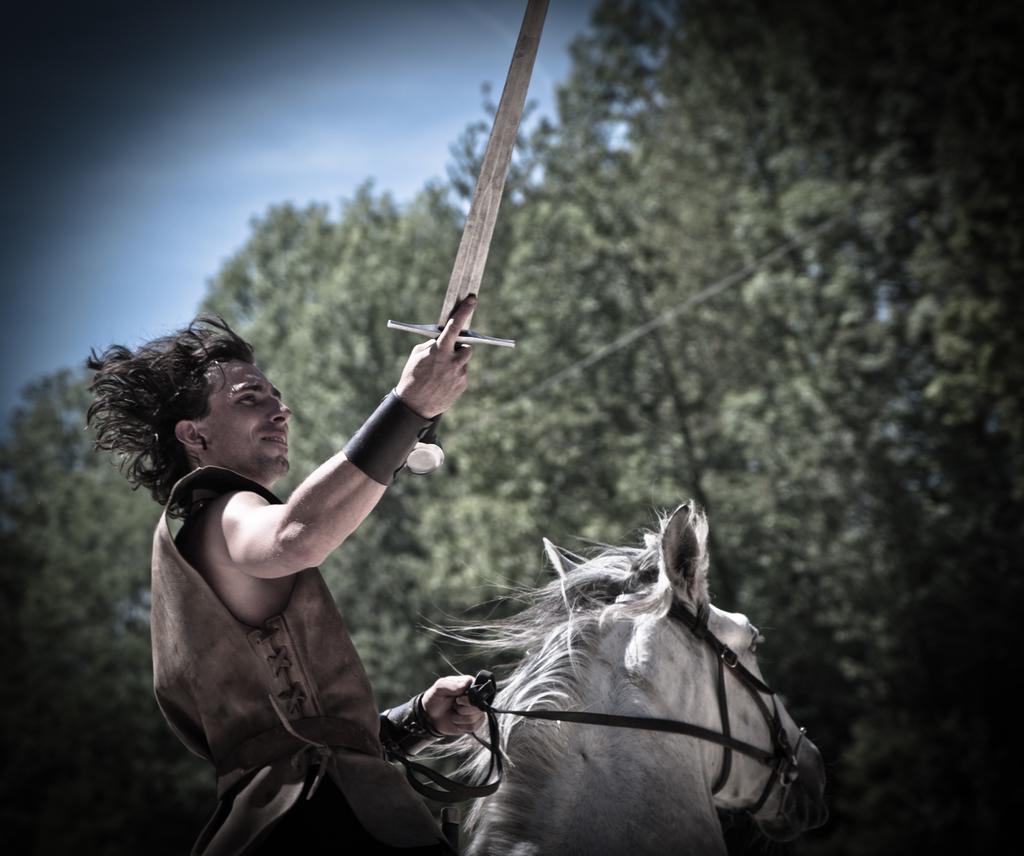How would you summarize this image in a sentence or two? In this picture we can see a man who is sitting on the horse. And he hold a knife with his hand. And in the background we can see some trees and this is the sky. 